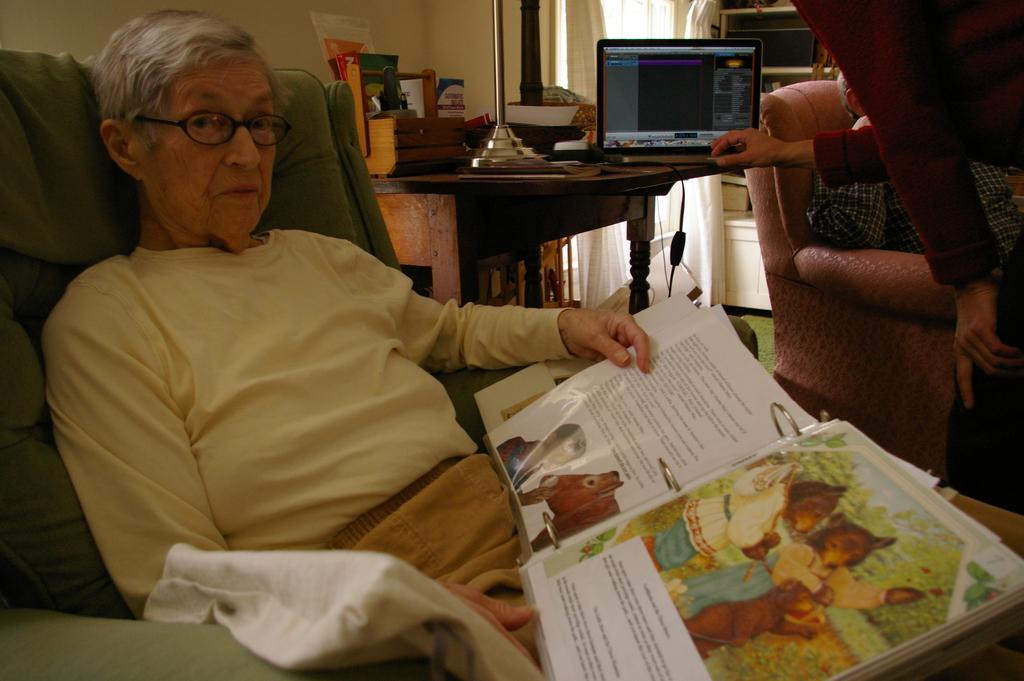In one or two sentences, can you explain what this image depicts? In the center of the image we can see one woman sitting on the sofa and she is holding a book. And we can see one cloth on the sofa. In the background there is a wall, table, curtains, sofa, one person sitting on the sofa, one person standing and holding some object and a few other objects. On the table, there is a monitor, keyboard, stand, basket, banners etc. 